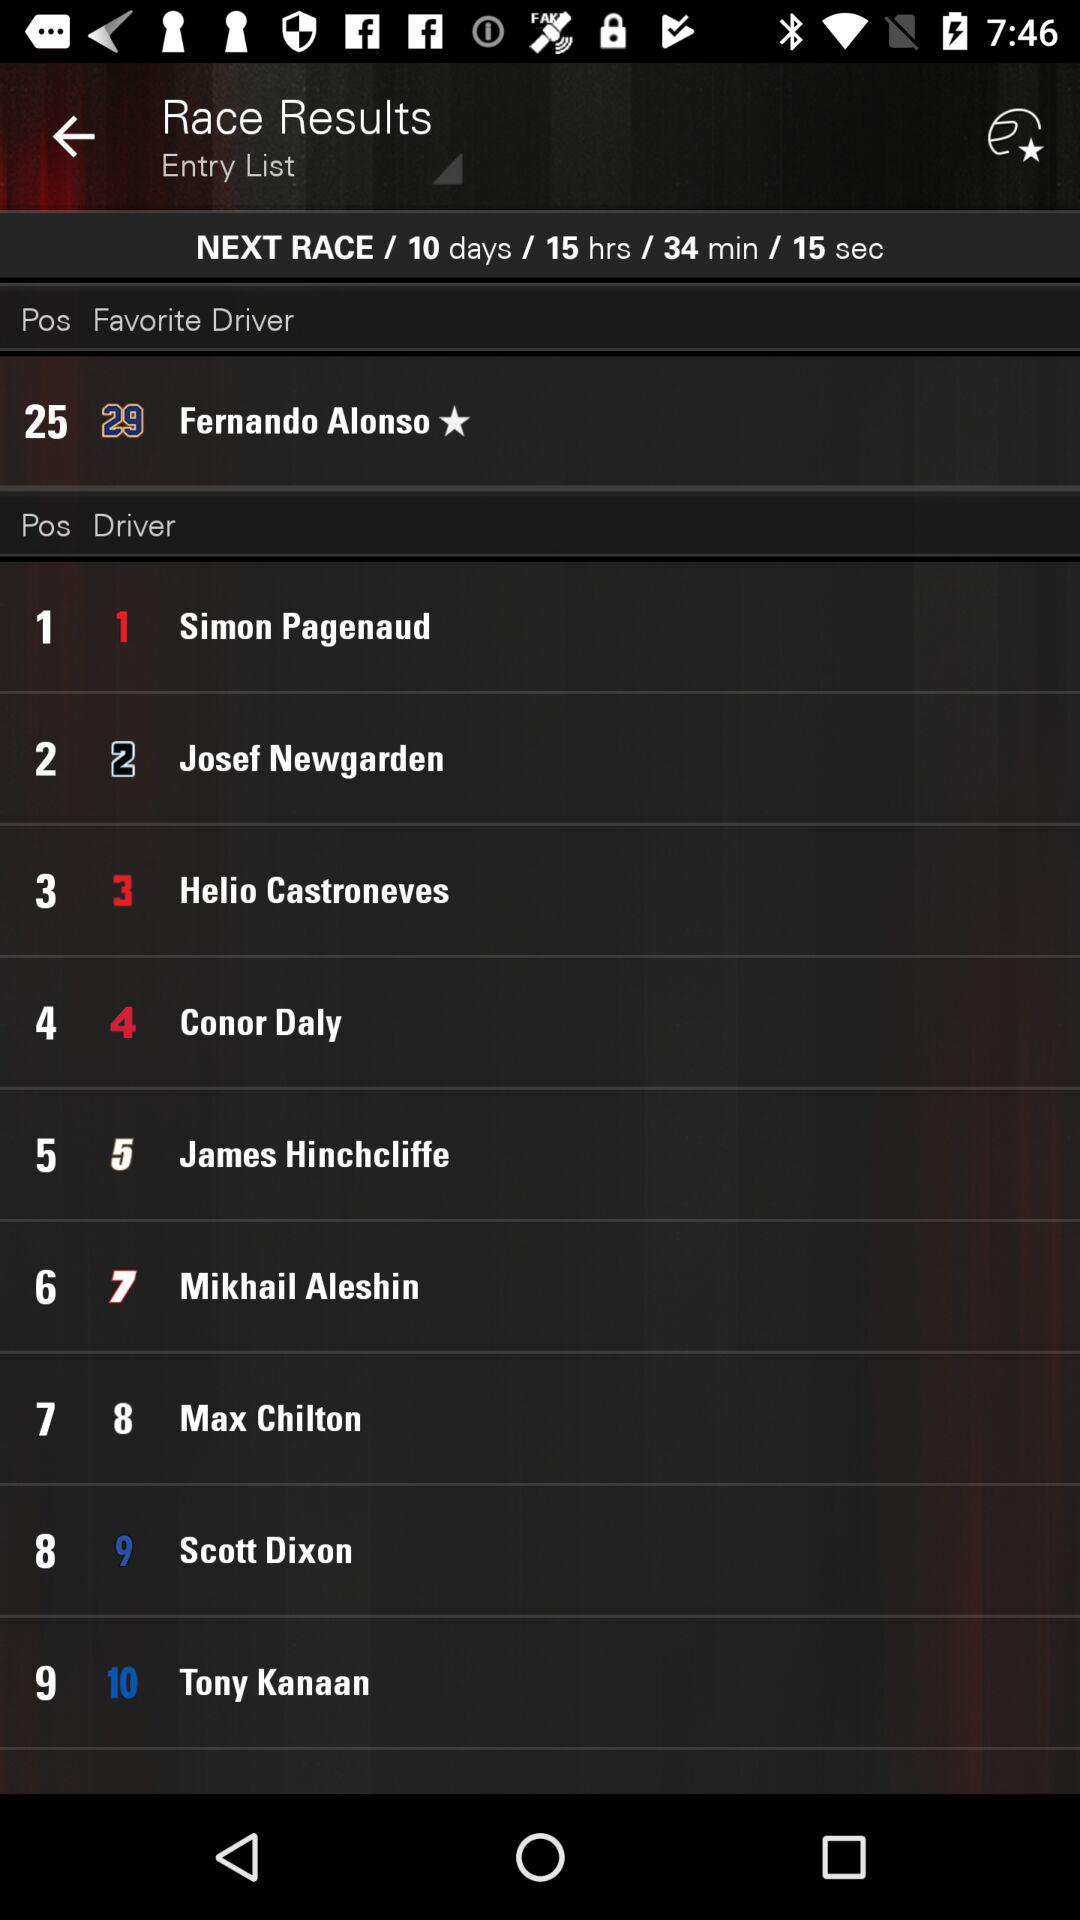Who is the winning driver?
When the provided information is insufficient, respond with <no answer>. <no answer> 